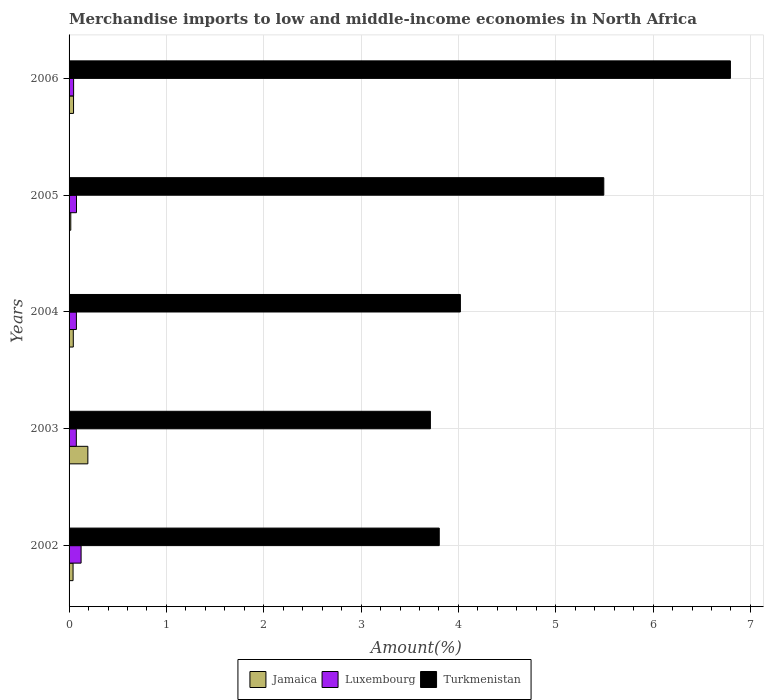How many different coloured bars are there?
Provide a short and direct response. 3. How many groups of bars are there?
Your answer should be very brief. 5. Are the number of bars per tick equal to the number of legend labels?
Offer a terse response. Yes. How many bars are there on the 4th tick from the top?
Make the answer very short. 3. What is the label of the 4th group of bars from the top?
Offer a very short reply. 2003. What is the percentage of amount earned from merchandise imports in Jamaica in 2002?
Offer a very short reply. 0.04. Across all years, what is the maximum percentage of amount earned from merchandise imports in Turkmenistan?
Offer a very short reply. 6.79. Across all years, what is the minimum percentage of amount earned from merchandise imports in Jamaica?
Ensure brevity in your answer.  0.02. In which year was the percentage of amount earned from merchandise imports in Luxembourg minimum?
Provide a succinct answer. 2006. What is the total percentage of amount earned from merchandise imports in Turkmenistan in the graph?
Give a very brief answer. 23.82. What is the difference between the percentage of amount earned from merchandise imports in Turkmenistan in 2002 and that in 2004?
Your answer should be very brief. -0.22. What is the difference between the percentage of amount earned from merchandise imports in Jamaica in 2006 and the percentage of amount earned from merchandise imports in Turkmenistan in 2005?
Your answer should be very brief. -5.45. What is the average percentage of amount earned from merchandise imports in Jamaica per year?
Provide a short and direct response. 0.07. In the year 2006, what is the difference between the percentage of amount earned from merchandise imports in Jamaica and percentage of amount earned from merchandise imports in Turkmenistan?
Ensure brevity in your answer.  -6.75. What is the ratio of the percentage of amount earned from merchandise imports in Turkmenistan in 2002 to that in 2004?
Keep it short and to the point. 0.95. Is the percentage of amount earned from merchandise imports in Turkmenistan in 2004 less than that in 2006?
Provide a succinct answer. Yes. What is the difference between the highest and the second highest percentage of amount earned from merchandise imports in Jamaica?
Give a very brief answer. 0.15. What is the difference between the highest and the lowest percentage of amount earned from merchandise imports in Jamaica?
Offer a very short reply. 0.18. In how many years, is the percentage of amount earned from merchandise imports in Jamaica greater than the average percentage of amount earned from merchandise imports in Jamaica taken over all years?
Make the answer very short. 1. Is the sum of the percentage of amount earned from merchandise imports in Turkmenistan in 2002 and 2005 greater than the maximum percentage of amount earned from merchandise imports in Luxembourg across all years?
Give a very brief answer. Yes. What does the 1st bar from the top in 2005 represents?
Make the answer very short. Turkmenistan. What does the 1st bar from the bottom in 2004 represents?
Ensure brevity in your answer.  Jamaica. How many bars are there?
Your answer should be very brief. 15. What is the difference between two consecutive major ticks on the X-axis?
Provide a succinct answer. 1. Does the graph contain any zero values?
Offer a very short reply. No. What is the title of the graph?
Provide a short and direct response. Merchandise imports to low and middle-income economies in North Africa. What is the label or title of the X-axis?
Keep it short and to the point. Amount(%). What is the label or title of the Y-axis?
Offer a terse response. Years. What is the Amount(%) in Jamaica in 2002?
Keep it short and to the point. 0.04. What is the Amount(%) of Luxembourg in 2002?
Keep it short and to the point. 0.12. What is the Amount(%) in Turkmenistan in 2002?
Your answer should be very brief. 3.8. What is the Amount(%) in Jamaica in 2003?
Your answer should be compact. 0.19. What is the Amount(%) in Luxembourg in 2003?
Your answer should be compact. 0.07. What is the Amount(%) of Turkmenistan in 2003?
Your answer should be very brief. 3.71. What is the Amount(%) in Jamaica in 2004?
Your response must be concise. 0.04. What is the Amount(%) in Luxembourg in 2004?
Provide a short and direct response. 0.08. What is the Amount(%) of Turkmenistan in 2004?
Offer a very short reply. 4.02. What is the Amount(%) in Jamaica in 2005?
Your answer should be very brief. 0.02. What is the Amount(%) in Luxembourg in 2005?
Provide a succinct answer. 0.08. What is the Amount(%) of Turkmenistan in 2005?
Your answer should be compact. 5.49. What is the Amount(%) in Jamaica in 2006?
Provide a short and direct response. 0.05. What is the Amount(%) of Luxembourg in 2006?
Your response must be concise. 0.05. What is the Amount(%) of Turkmenistan in 2006?
Give a very brief answer. 6.79. Across all years, what is the maximum Amount(%) in Jamaica?
Give a very brief answer. 0.19. Across all years, what is the maximum Amount(%) of Luxembourg?
Give a very brief answer. 0.12. Across all years, what is the maximum Amount(%) in Turkmenistan?
Provide a succinct answer. 6.79. Across all years, what is the minimum Amount(%) in Jamaica?
Provide a short and direct response. 0.02. Across all years, what is the minimum Amount(%) of Luxembourg?
Offer a very short reply. 0.05. Across all years, what is the minimum Amount(%) in Turkmenistan?
Provide a short and direct response. 3.71. What is the total Amount(%) of Jamaica in the graph?
Provide a succinct answer. 0.34. What is the total Amount(%) of Luxembourg in the graph?
Your response must be concise. 0.4. What is the total Amount(%) in Turkmenistan in the graph?
Provide a short and direct response. 23.82. What is the difference between the Amount(%) in Jamaica in 2002 and that in 2003?
Give a very brief answer. -0.15. What is the difference between the Amount(%) of Luxembourg in 2002 and that in 2003?
Your response must be concise. 0.05. What is the difference between the Amount(%) in Turkmenistan in 2002 and that in 2003?
Provide a succinct answer. 0.09. What is the difference between the Amount(%) of Jamaica in 2002 and that in 2004?
Make the answer very short. -0. What is the difference between the Amount(%) in Luxembourg in 2002 and that in 2004?
Ensure brevity in your answer.  0.05. What is the difference between the Amount(%) in Turkmenistan in 2002 and that in 2004?
Your response must be concise. -0.22. What is the difference between the Amount(%) in Jamaica in 2002 and that in 2005?
Ensure brevity in your answer.  0.02. What is the difference between the Amount(%) of Luxembourg in 2002 and that in 2005?
Provide a short and direct response. 0.05. What is the difference between the Amount(%) in Turkmenistan in 2002 and that in 2005?
Make the answer very short. -1.69. What is the difference between the Amount(%) of Jamaica in 2002 and that in 2006?
Make the answer very short. -0.01. What is the difference between the Amount(%) of Luxembourg in 2002 and that in 2006?
Offer a terse response. 0.08. What is the difference between the Amount(%) in Turkmenistan in 2002 and that in 2006?
Provide a succinct answer. -2.99. What is the difference between the Amount(%) in Jamaica in 2003 and that in 2004?
Make the answer very short. 0.15. What is the difference between the Amount(%) in Luxembourg in 2003 and that in 2004?
Give a very brief answer. -0. What is the difference between the Amount(%) of Turkmenistan in 2003 and that in 2004?
Your answer should be compact. -0.31. What is the difference between the Amount(%) of Jamaica in 2003 and that in 2005?
Offer a terse response. 0.18. What is the difference between the Amount(%) of Luxembourg in 2003 and that in 2005?
Offer a terse response. -0. What is the difference between the Amount(%) of Turkmenistan in 2003 and that in 2005?
Provide a short and direct response. -1.78. What is the difference between the Amount(%) in Jamaica in 2003 and that in 2006?
Give a very brief answer. 0.15. What is the difference between the Amount(%) in Luxembourg in 2003 and that in 2006?
Your answer should be very brief. 0.03. What is the difference between the Amount(%) in Turkmenistan in 2003 and that in 2006?
Provide a succinct answer. -3.08. What is the difference between the Amount(%) in Jamaica in 2004 and that in 2005?
Give a very brief answer. 0.03. What is the difference between the Amount(%) of Luxembourg in 2004 and that in 2005?
Your answer should be compact. -0. What is the difference between the Amount(%) of Turkmenistan in 2004 and that in 2005?
Keep it short and to the point. -1.47. What is the difference between the Amount(%) of Jamaica in 2004 and that in 2006?
Provide a short and direct response. -0. What is the difference between the Amount(%) in Luxembourg in 2004 and that in 2006?
Give a very brief answer. 0.03. What is the difference between the Amount(%) of Turkmenistan in 2004 and that in 2006?
Make the answer very short. -2.77. What is the difference between the Amount(%) of Jamaica in 2005 and that in 2006?
Make the answer very short. -0.03. What is the difference between the Amount(%) of Luxembourg in 2005 and that in 2006?
Make the answer very short. 0.03. What is the difference between the Amount(%) in Turkmenistan in 2005 and that in 2006?
Keep it short and to the point. -1.3. What is the difference between the Amount(%) in Jamaica in 2002 and the Amount(%) in Luxembourg in 2003?
Your response must be concise. -0.03. What is the difference between the Amount(%) of Jamaica in 2002 and the Amount(%) of Turkmenistan in 2003?
Make the answer very short. -3.67. What is the difference between the Amount(%) in Luxembourg in 2002 and the Amount(%) in Turkmenistan in 2003?
Make the answer very short. -3.59. What is the difference between the Amount(%) in Jamaica in 2002 and the Amount(%) in Luxembourg in 2004?
Your response must be concise. -0.03. What is the difference between the Amount(%) in Jamaica in 2002 and the Amount(%) in Turkmenistan in 2004?
Your answer should be compact. -3.98. What is the difference between the Amount(%) of Luxembourg in 2002 and the Amount(%) of Turkmenistan in 2004?
Provide a succinct answer. -3.9. What is the difference between the Amount(%) in Jamaica in 2002 and the Amount(%) in Luxembourg in 2005?
Provide a succinct answer. -0.04. What is the difference between the Amount(%) in Jamaica in 2002 and the Amount(%) in Turkmenistan in 2005?
Offer a very short reply. -5.45. What is the difference between the Amount(%) in Luxembourg in 2002 and the Amount(%) in Turkmenistan in 2005?
Keep it short and to the point. -5.37. What is the difference between the Amount(%) in Jamaica in 2002 and the Amount(%) in Luxembourg in 2006?
Your answer should be very brief. -0.01. What is the difference between the Amount(%) of Jamaica in 2002 and the Amount(%) of Turkmenistan in 2006?
Ensure brevity in your answer.  -6.75. What is the difference between the Amount(%) of Luxembourg in 2002 and the Amount(%) of Turkmenistan in 2006?
Make the answer very short. -6.67. What is the difference between the Amount(%) of Jamaica in 2003 and the Amount(%) of Luxembourg in 2004?
Offer a very short reply. 0.12. What is the difference between the Amount(%) of Jamaica in 2003 and the Amount(%) of Turkmenistan in 2004?
Your response must be concise. -3.83. What is the difference between the Amount(%) of Luxembourg in 2003 and the Amount(%) of Turkmenistan in 2004?
Give a very brief answer. -3.95. What is the difference between the Amount(%) in Jamaica in 2003 and the Amount(%) in Luxembourg in 2005?
Offer a very short reply. 0.12. What is the difference between the Amount(%) of Jamaica in 2003 and the Amount(%) of Turkmenistan in 2005?
Keep it short and to the point. -5.3. What is the difference between the Amount(%) of Luxembourg in 2003 and the Amount(%) of Turkmenistan in 2005?
Keep it short and to the point. -5.42. What is the difference between the Amount(%) of Jamaica in 2003 and the Amount(%) of Luxembourg in 2006?
Offer a terse response. 0.15. What is the difference between the Amount(%) of Jamaica in 2003 and the Amount(%) of Turkmenistan in 2006?
Your response must be concise. -6.6. What is the difference between the Amount(%) in Luxembourg in 2003 and the Amount(%) in Turkmenistan in 2006?
Ensure brevity in your answer.  -6.72. What is the difference between the Amount(%) of Jamaica in 2004 and the Amount(%) of Luxembourg in 2005?
Provide a succinct answer. -0.03. What is the difference between the Amount(%) of Jamaica in 2004 and the Amount(%) of Turkmenistan in 2005?
Offer a terse response. -5.45. What is the difference between the Amount(%) in Luxembourg in 2004 and the Amount(%) in Turkmenistan in 2005?
Provide a succinct answer. -5.42. What is the difference between the Amount(%) of Jamaica in 2004 and the Amount(%) of Luxembourg in 2006?
Keep it short and to the point. -0. What is the difference between the Amount(%) in Jamaica in 2004 and the Amount(%) in Turkmenistan in 2006?
Provide a short and direct response. -6.75. What is the difference between the Amount(%) of Luxembourg in 2004 and the Amount(%) of Turkmenistan in 2006?
Provide a succinct answer. -6.72. What is the difference between the Amount(%) of Jamaica in 2005 and the Amount(%) of Luxembourg in 2006?
Provide a short and direct response. -0.03. What is the difference between the Amount(%) in Jamaica in 2005 and the Amount(%) in Turkmenistan in 2006?
Offer a very short reply. -6.78. What is the difference between the Amount(%) in Luxembourg in 2005 and the Amount(%) in Turkmenistan in 2006?
Your answer should be very brief. -6.72. What is the average Amount(%) in Jamaica per year?
Offer a very short reply. 0.07. What is the average Amount(%) in Luxembourg per year?
Keep it short and to the point. 0.08. What is the average Amount(%) in Turkmenistan per year?
Give a very brief answer. 4.76. In the year 2002, what is the difference between the Amount(%) of Jamaica and Amount(%) of Luxembourg?
Give a very brief answer. -0.08. In the year 2002, what is the difference between the Amount(%) of Jamaica and Amount(%) of Turkmenistan?
Your response must be concise. -3.76. In the year 2002, what is the difference between the Amount(%) in Luxembourg and Amount(%) in Turkmenistan?
Give a very brief answer. -3.68. In the year 2003, what is the difference between the Amount(%) in Jamaica and Amount(%) in Luxembourg?
Your answer should be very brief. 0.12. In the year 2003, what is the difference between the Amount(%) in Jamaica and Amount(%) in Turkmenistan?
Offer a terse response. -3.52. In the year 2003, what is the difference between the Amount(%) in Luxembourg and Amount(%) in Turkmenistan?
Ensure brevity in your answer.  -3.64. In the year 2004, what is the difference between the Amount(%) in Jamaica and Amount(%) in Luxembourg?
Your answer should be compact. -0.03. In the year 2004, what is the difference between the Amount(%) in Jamaica and Amount(%) in Turkmenistan?
Provide a succinct answer. -3.98. In the year 2004, what is the difference between the Amount(%) in Luxembourg and Amount(%) in Turkmenistan?
Your answer should be compact. -3.94. In the year 2005, what is the difference between the Amount(%) in Jamaica and Amount(%) in Luxembourg?
Keep it short and to the point. -0.06. In the year 2005, what is the difference between the Amount(%) in Jamaica and Amount(%) in Turkmenistan?
Offer a very short reply. -5.48. In the year 2005, what is the difference between the Amount(%) of Luxembourg and Amount(%) of Turkmenistan?
Provide a short and direct response. -5.42. In the year 2006, what is the difference between the Amount(%) of Jamaica and Amount(%) of Luxembourg?
Your response must be concise. -0. In the year 2006, what is the difference between the Amount(%) in Jamaica and Amount(%) in Turkmenistan?
Keep it short and to the point. -6.75. In the year 2006, what is the difference between the Amount(%) in Luxembourg and Amount(%) in Turkmenistan?
Keep it short and to the point. -6.75. What is the ratio of the Amount(%) in Jamaica in 2002 to that in 2003?
Keep it short and to the point. 0.21. What is the ratio of the Amount(%) of Luxembourg in 2002 to that in 2003?
Offer a very short reply. 1.66. What is the ratio of the Amount(%) of Turkmenistan in 2002 to that in 2003?
Your response must be concise. 1.02. What is the ratio of the Amount(%) in Jamaica in 2002 to that in 2004?
Give a very brief answer. 0.95. What is the ratio of the Amount(%) in Luxembourg in 2002 to that in 2004?
Provide a succinct answer. 1.64. What is the ratio of the Amount(%) in Turkmenistan in 2002 to that in 2004?
Offer a terse response. 0.95. What is the ratio of the Amount(%) of Jamaica in 2002 to that in 2005?
Your answer should be very brief. 2.33. What is the ratio of the Amount(%) in Luxembourg in 2002 to that in 2005?
Your answer should be compact. 1.62. What is the ratio of the Amount(%) in Turkmenistan in 2002 to that in 2005?
Provide a short and direct response. 0.69. What is the ratio of the Amount(%) in Jamaica in 2002 to that in 2006?
Provide a succinct answer. 0.89. What is the ratio of the Amount(%) of Luxembourg in 2002 to that in 2006?
Offer a very short reply. 2.65. What is the ratio of the Amount(%) in Turkmenistan in 2002 to that in 2006?
Provide a short and direct response. 0.56. What is the ratio of the Amount(%) in Jamaica in 2003 to that in 2004?
Offer a very short reply. 4.45. What is the ratio of the Amount(%) of Luxembourg in 2003 to that in 2004?
Give a very brief answer. 0.99. What is the ratio of the Amount(%) of Turkmenistan in 2003 to that in 2004?
Provide a short and direct response. 0.92. What is the ratio of the Amount(%) in Jamaica in 2003 to that in 2005?
Your answer should be very brief. 10.97. What is the ratio of the Amount(%) in Luxembourg in 2003 to that in 2005?
Give a very brief answer. 0.98. What is the ratio of the Amount(%) of Turkmenistan in 2003 to that in 2005?
Offer a very short reply. 0.68. What is the ratio of the Amount(%) of Jamaica in 2003 to that in 2006?
Provide a short and direct response. 4.19. What is the ratio of the Amount(%) of Luxembourg in 2003 to that in 2006?
Your response must be concise. 1.6. What is the ratio of the Amount(%) in Turkmenistan in 2003 to that in 2006?
Offer a terse response. 0.55. What is the ratio of the Amount(%) in Jamaica in 2004 to that in 2005?
Provide a short and direct response. 2.47. What is the ratio of the Amount(%) of Luxembourg in 2004 to that in 2005?
Offer a very short reply. 0.99. What is the ratio of the Amount(%) in Turkmenistan in 2004 to that in 2005?
Keep it short and to the point. 0.73. What is the ratio of the Amount(%) in Jamaica in 2004 to that in 2006?
Provide a succinct answer. 0.94. What is the ratio of the Amount(%) in Luxembourg in 2004 to that in 2006?
Keep it short and to the point. 1.61. What is the ratio of the Amount(%) in Turkmenistan in 2004 to that in 2006?
Offer a very short reply. 0.59. What is the ratio of the Amount(%) in Jamaica in 2005 to that in 2006?
Ensure brevity in your answer.  0.38. What is the ratio of the Amount(%) in Luxembourg in 2005 to that in 2006?
Offer a terse response. 1.64. What is the ratio of the Amount(%) in Turkmenistan in 2005 to that in 2006?
Provide a succinct answer. 0.81. What is the difference between the highest and the second highest Amount(%) in Jamaica?
Offer a terse response. 0.15. What is the difference between the highest and the second highest Amount(%) of Luxembourg?
Offer a terse response. 0.05. What is the difference between the highest and the second highest Amount(%) of Turkmenistan?
Keep it short and to the point. 1.3. What is the difference between the highest and the lowest Amount(%) of Jamaica?
Keep it short and to the point. 0.18. What is the difference between the highest and the lowest Amount(%) of Luxembourg?
Provide a short and direct response. 0.08. What is the difference between the highest and the lowest Amount(%) of Turkmenistan?
Provide a succinct answer. 3.08. 